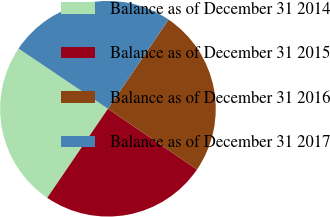Convert chart to OTSL. <chart><loc_0><loc_0><loc_500><loc_500><pie_chart><fcel>Balance as of December 31 2014<fcel>Balance as of December 31 2015<fcel>Balance as of December 31 2016<fcel>Balance as of December 31 2017<nl><fcel>24.91%<fcel>24.99%<fcel>25.03%<fcel>25.07%<nl></chart> 